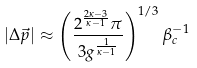<formula> <loc_0><loc_0><loc_500><loc_500>| \Delta \vec { p } | \approx \left ( \frac { 2 ^ { \frac { 2 \kappa - 3 } { \kappa - 1 } } \pi } { 3 g ^ { \frac { 1 } { \kappa - 1 } } } \right ) ^ { 1 / 3 } \beta _ { c } ^ { - 1 }</formula> 